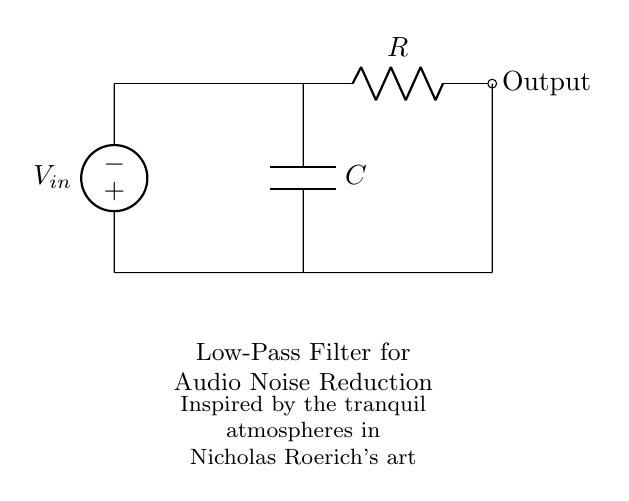What is the type of filter represented in the circuit? The circuit shows a low-pass filter, which allows signals with a frequency lower than a certain cutoff frequency to pass through while attenuating higher frequencies.
Answer: low-pass filter What does the capacitor do in this circuit? The capacitor stores and releases electrical energy, influencing the time constant of the filter and helping to block high-frequency noise while allowing low-frequency signals to pass.
Answer: blocks high-frequency noise What is the role of the resistor in the low-pass filter? The resistor works with the capacitor to set the cutoff frequency of the filter, defining how the circuit responds to different frequencies.
Answer: sets cutoff frequency What is the input voltage source labeled as in the circuit? The voltage source connected to the circuit is labeled as Vin, representing the incoming audio signal that needs filtering.
Answer: Vin How many main components are shown in the circuit? The circuit contains two main components: a resistor and a capacitor, both essential for its function as a low-pass filter.
Answer: two What kind of performance does this filter aim to achieve in audio systems during art exhibitions? The filter aims to reduce unwanted noise while preserving the quality of the audio signal, creating a more tranquil listening experience suitable for artistic environments.
Answer: noise reduction 